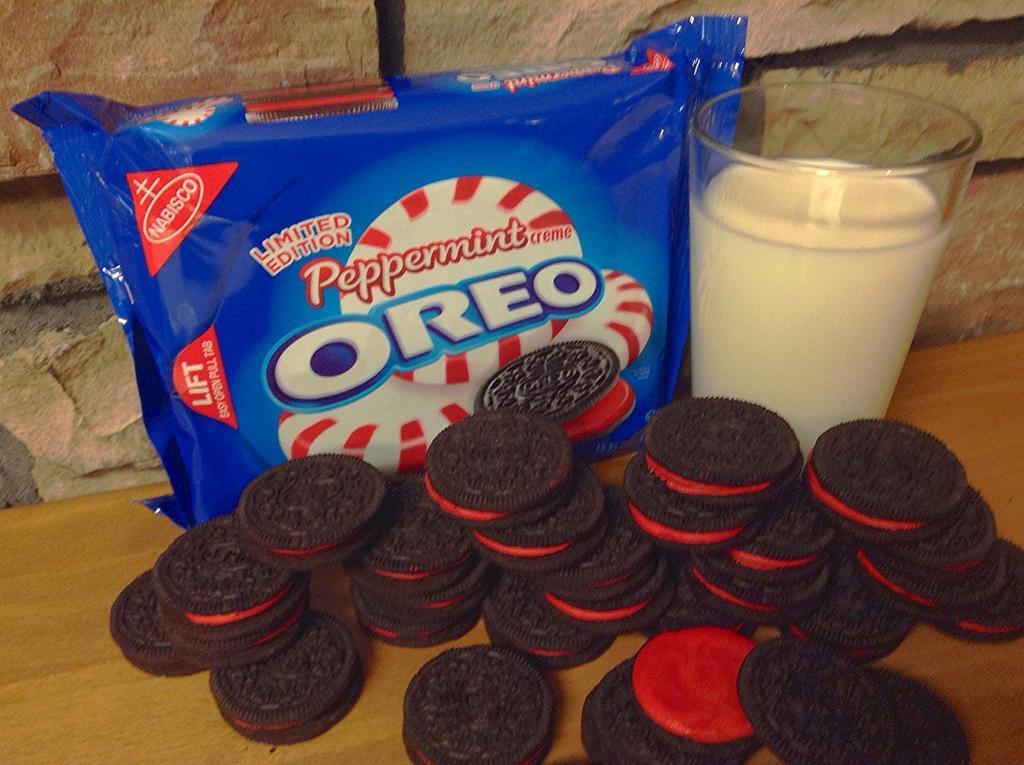Can you describe this image briefly? In this image we can see some biscuits, milk in a glass and a biscuit packet on a surface, also we can see a wall. 